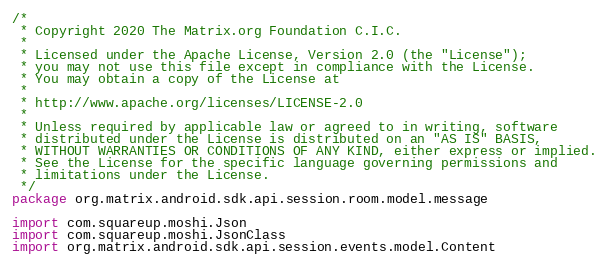Convert code to text. <code><loc_0><loc_0><loc_500><loc_500><_Kotlin_>/*
 * Copyright 2020 The Matrix.org Foundation C.I.C.
 *
 * Licensed under the Apache License, Version 2.0 (the "License");
 * you may not use this file except in compliance with the License.
 * You may obtain a copy of the License at
 *
 * http://www.apache.org/licenses/LICENSE-2.0
 *
 * Unless required by applicable law or agreed to in writing, software
 * distributed under the License is distributed on an "AS IS" BASIS,
 * WITHOUT WARRANTIES OR CONDITIONS OF ANY KIND, either express or implied.
 * See the License for the specific language governing permissions and
 * limitations under the License.
 */
package org.matrix.android.sdk.api.session.room.model.message

import com.squareup.moshi.Json
import com.squareup.moshi.JsonClass
import org.matrix.android.sdk.api.session.events.model.Content</code> 